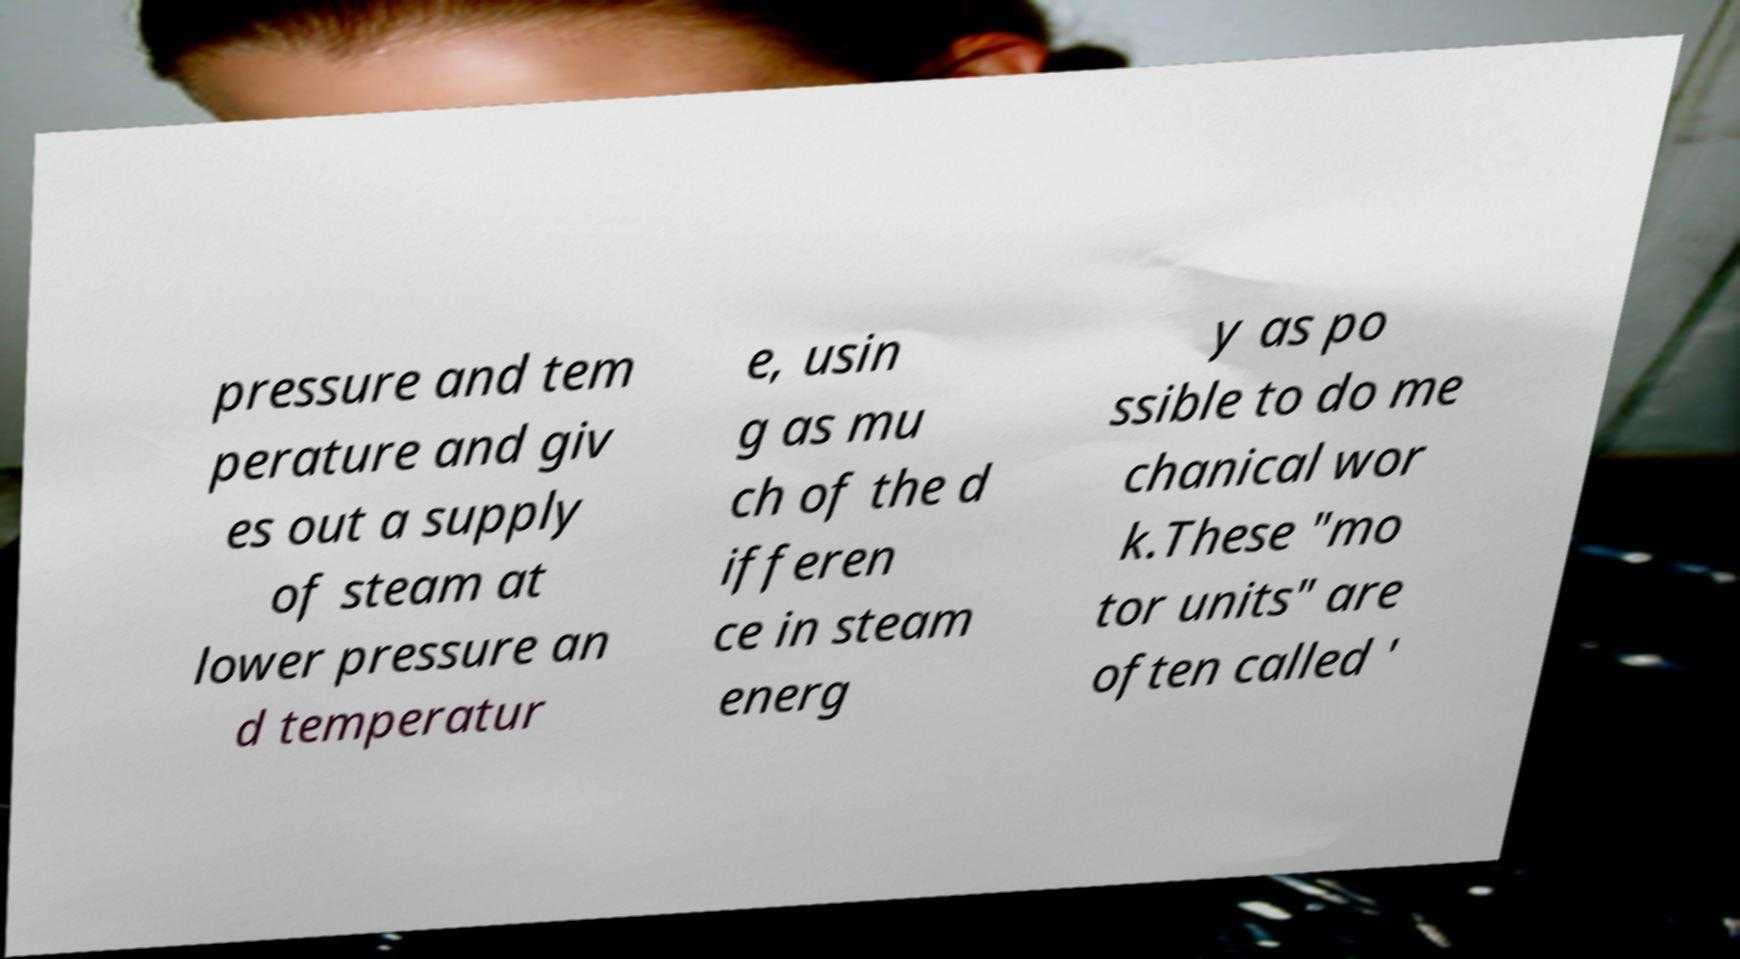Can you read and provide the text displayed in the image?This photo seems to have some interesting text. Can you extract and type it out for me? pressure and tem perature and giv es out a supply of steam at lower pressure an d temperatur e, usin g as mu ch of the d ifferen ce in steam energ y as po ssible to do me chanical wor k.These "mo tor units" are often called ' 